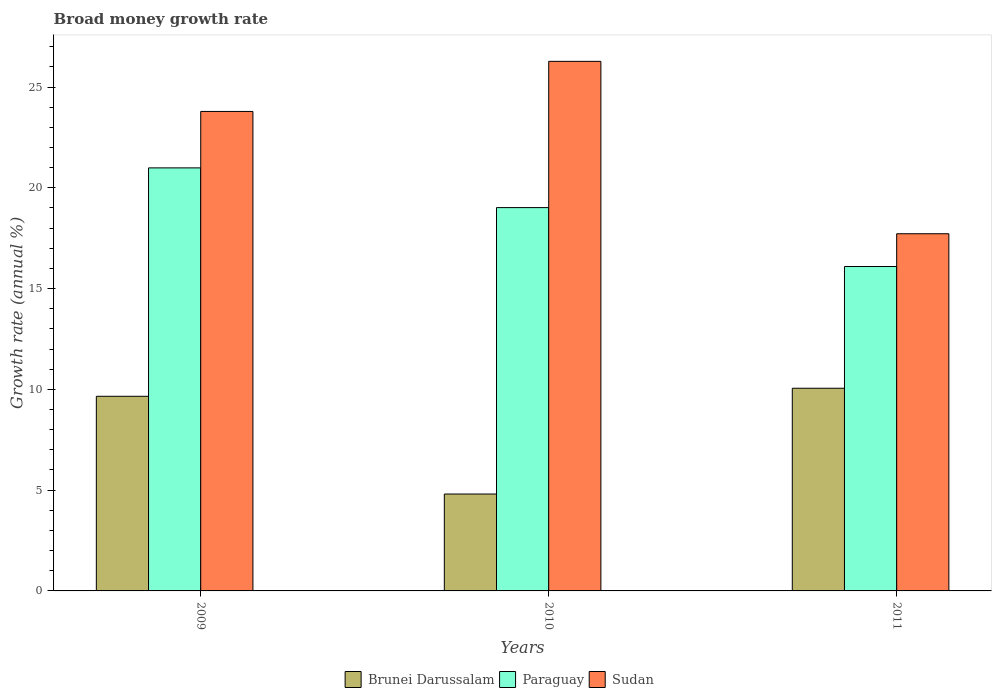How many different coloured bars are there?
Provide a succinct answer. 3. Are the number of bars on each tick of the X-axis equal?
Ensure brevity in your answer.  Yes. What is the label of the 2nd group of bars from the left?
Your answer should be very brief. 2010. What is the growth rate in Paraguay in 2009?
Offer a terse response. 20.99. Across all years, what is the maximum growth rate in Paraguay?
Offer a very short reply. 20.99. Across all years, what is the minimum growth rate in Brunei Darussalam?
Offer a terse response. 4.81. What is the total growth rate in Paraguay in the graph?
Keep it short and to the point. 56.1. What is the difference between the growth rate in Sudan in 2009 and that in 2010?
Your answer should be very brief. -2.49. What is the difference between the growth rate in Brunei Darussalam in 2011 and the growth rate in Sudan in 2009?
Keep it short and to the point. -13.73. What is the average growth rate in Sudan per year?
Your answer should be compact. 22.59. In the year 2011, what is the difference between the growth rate in Sudan and growth rate in Brunei Darussalam?
Offer a very short reply. 7.67. In how many years, is the growth rate in Paraguay greater than 25 %?
Your answer should be very brief. 0. What is the ratio of the growth rate in Brunei Darussalam in 2009 to that in 2010?
Offer a very short reply. 2.01. Is the growth rate in Paraguay in 2010 less than that in 2011?
Offer a very short reply. No. Is the difference between the growth rate in Sudan in 2009 and 2011 greater than the difference between the growth rate in Brunei Darussalam in 2009 and 2011?
Provide a short and direct response. Yes. What is the difference between the highest and the second highest growth rate in Sudan?
Give a very brief answer. 2.49. What is the difference between the highest and the lowest growth rate in Sudan?
Your answer should be compact. 8.55. In how many years, is the growth rate in Sudan greater than the average growth rate in Sudan taken over all years?
Offer a very short reply. 2. What does the 2nd bar from the left in 2010 represents?
Provide a short and direct response. Paraguay. What does the 1st bar from the right in 2009 represents?
Ensure brevity in your answer.  Sudan. Is it the case that in every year, the sum of the growth rate in Sudan and growth rate in Brunei Darussalam is greater than the growth rate in Paraguay?
Offer a very short reply. Yes. Are the values on the major ticks of Y-axis written in scientific E-notation?
Make the answer very short. No. Does the graph contain any zero values?
Your answer should be very brief. No. Does the graph contain grids?
Offer a very short reply. No. How are the legend labels stacked?
Offer a terse response. Horizontal. What is the title of the graph?
Make the answer very short. Broad money growth rate. Does "Guatemala" appear as one of the legend labels in the graph?
Offer a terse response. No. What is the label or title of the X-axis?
Provide a short and direct response. Years. What is the label or title of the Y-axis?
Offer a very short reply. Growth rate (annual %). What is the Growth rate (annual %) in Brunei Darussalam in 2009?
Keep it short and to the point. 9.66. What is the Growth rate (annual %) in Paraguay in 2009?
Offer a very short reply. 20.99. What is the Growth rate (annual %) of Sudan in 2009?
Keep it short and to the point. 23.79. What is the Growth rate (annual %) in Brunei Darussalam in 2010?
Your answer should be compact. 4.81. What is the Growth rate (annual %) of Paraguay in 2010?
Keep it short and to the point. 19.02. What is the Growth rate (annual %) in Sudan in 2010?
Your response must be concise. 26.27. What is the Growth rate (annual %) of Brunei Darussalam in 2011?
Keep it short and to the point. 10.05. What is the Growth rate (annual %) of Paraguay in 2011?
Ensure brevity in your answer.  16.09. What is the Growth rate (annual %) in Sudan in 2011?
Offer a terse response. 17.72. Across all years, what is the maximum Growth rate (annual %) of Brunei Darussalam?
Make the answer very short. 10.05. Across all years, what is the maximum Growth rate (annual %) of Paraguay?
Offer a terse response. 20.99. Across all years, what is the maximum Growth rate (annual %) in Sudan?
Give a very brief answer. 26.27. Across all years, what is the minimum Growth rate (annual %) of Brunei Darussalam?
Your answer should be compact. 4.81. Across all years, what is the minimum Growth rate (annual %) of Paraguay?
Give a very brief answer. 16.09. Across all years, what is the minimum Growth rate (annual %) of Sudan?
Ensure brevity in your answer.  17.72. What is the total Growth rate (annual %) in Brunei Darussalam in the graph?
Ensure brevity in your answer.  24.52. What is the total Growth rate (annual %) in Paraguay in the graph?
Give a very brief answer. 56.1. What is the total Growth rate (annual %) of Sudan in the graph?
Provide a short and direct response. 67.78. What is the difference between the Growth rate (annual %) of Brunei Darussalam in 2009 and that in 2010?
Your answer should be very brief. 4.85. What is the difference between the Growth rate (annual %) of Paraguay in 2009 and that in 2010?
Provide a short and direct response. 1.97. What is the difference between the Growth rate (annual %) of Sudan in 2009 and that in 2010?
Provide a short and direct response. -2.49. What is the difference between the Growth rate (annual %) of Brunei Darussalam in 2009 and that in 2011?
Ensure brevity in your answer.  -0.4. What is the difference between the Growth rate (annual %) of Paraguay in 2009 and that in 2011?
Ensure brevity in your answer.  4.89. What is the difference between the Growth rate (annual %) in Sudan in 2009 and that in 2011?
Keep it short and to the point. 6.07. What is the difference between the Growth rate (annual %) of Brunei Darussalam in 2010 and that in 2011?
Your answer should be very brief. -5.25. What is the difference between the Growth rate (annual %) in Paraguay in 2010 and that in 2011?
Offer a very short reply. 2.92. What is the difference between the Growth rate (annual %) of Sudan in 2010 and that in 2011?
Provide a short and direct response. 8.55. What is the difference between the Growth rate (annual %) of Brunei Darussalam in 2009 and the Growth rate (annual %) of Paraguay in 2010?
Provide a succinct answer. -9.36. What is the difference between the Growth rate (annual %) in Brunei Darussalam in 2009 and the Growth rate (annual %) in Sudan in 2010?
Your answer should be very brief. -16.62. What is the difference between the Growth rate (annual %) of Paraguay in 2009 and the Growth rate (annual %) of Sudan in 2010?
Offer a very short reply. -5.29. What is the difference between the Growth rate (annual %) in Brunei Darussalam in 2009 and the Growth rate (annual %) in Paraguay in 2011?
Provide a succinct answer. -6.44. What is the difference between the Growth rate (annual %) in Brunei Darussalam in 2009 and the Growth rate (annual %) in Sudan in 2011?
Offer a terse response. -8.06. What is the difference between the Growth rate (annual %) of Paraguay in 2009 and the Growth rate (annual %) of Sudan in 2011?
Provide a succinct answer. 3.27. What is the difference between the Growth rate (annual %) in Brunei Darussalam in 2010 and the Growth rate (annual %) in Paraguay in 2011?
Make the answer very short. -11.29. What is the difference between the Growth rate (annual %) in Brunei Darussalam in 2010 and the Growth rate (annual %) in Sudan in 2011?
Ensure brevity in your answer.  -12.91. What is the difference between the Growth rate (annual %) in Paraguay in 2010 and the Growth rate (annual %) in Sudan in 2011?
Make the answer very short. 1.3. What is the average Growth rate (annual %) of Brunei Darussalam per year?
Offer a very short reply. 8.17. What is the average Growth rate (annual %) in Paraguay per year?
Your response must be concise. 18.7. What is the average Growth rate (annual %) in Sudan per year?
Make the answer very short. 22.59. In the year 2009, what is the difference between the Growth rate (annual %) of Brunei Darussalam and Growth rate (annual %) of Paraguay?
Keep it short and to the point. -11.33. In the year 2009, what is the difference between the Growth rate (annual %) in Brunei Darussalam and Growth rate (annual %) in Sudan?
Provide a short and direct response. -14.13. In the year 2009, what is the difference between the Growth rate (annual %) in Paraguay and Growth rate (annual %) in Sudan?
Ensure brevity in your answer.  -2.8. In the year 2010, what is the difference between the Growth rate (annual %) of Brunei Darussalam and Growth rate (annual %) of Paraguay?
Offer a very short reply. -14.21. In the year 2010, what is the difference between the Growth rate (annual %) of Brunei Darussalam and Growth rate (annual %) of Sudan?
Provide a succinct answer. -21.47. In the year 2010, what is the difference between the Growth rate (annual %) of Paraguay and Growth rate (annual %) of Sudan?
Make the answer very short. -7.26. In the year 2011, what is the difference between the Growth rate (annual %) in Brunei Darussalam and Growth rate (annual %) in Paraguay?
Make the answer very short. -6.04. In the year 2011, what is the difference between the Growth rate (annual %) in Brunei Darussalam and Growth rate (annual %) in Sudan?
Your answer should be compact. -7.67. In the year 2011, what is the difference between the Growth rate (annual %) of Paraguay and Growth rate (annual %) of Sudan?
Offer a very short reply. -1.63. What is the ratio of the Growth rate (annual %) in Brunei Darussalam in 2009 to that in 2010?
Make the answer very short. 2.01. What is the ratio of the Growth rate (annual %) in Paraguay in 2009 to that in 2010?
Give a very brief answer. 1.1. What is the ratio of the Growth rate (annual %) in Sudan in 2009 to that in 2010?
Your answer should be compact. 0.91. What is the ratio of the Growth rate (annual %) in Brunei Darussalam in 2009 to that in 2011?
Ensure brevity in your answer.  0.96. What is the ratio of the Growth rate (annual %) in Paraguay in 2009 to that in 2011?
Offer a terse response. 1.3. What is the ratio of the Growth rate (annual %) of Sudan in 2009 to that in 2011?
Provide a succinct answer. 1.34. What is the ratio of the Growth rate (annual %) of Brunei Darussalam in 2010 to that in 2011?
Your answer should be compact. 0.48. What is the ratio of the Growth rate (annual %) of Paraguay in 2010 to that in 2011?
Your answer should be compact. 1.18. What is the ratio of the Growth rate (annual %) in Sudan in 2010 to that in 2011?
Give a very brief answer. 1.48. What is the difference between the highest and the second highest Growth rate (annual %) in Brunei Darussalam?
Your answer should be compact. 0.4. What is the difference between the highest and the second highest Growth rate (annual %) of Paraguay?
Offer a very short reply. 1.97. What is the difference between the highest and the second highest Growth rate (annual %) in Sudan?
Make the answer very short. 2.49. What is the difference between the highest and the lowest Growth rate (annual %) in Brunei Darussalam?
Offer a very short reply. 5.25. What is the difference between the highest and the lowest Growth rate (annual %) of Paraguay?
Give a very brief answer. 4.89. What is the difference between the highest and the lowest Growth rate (annual %) in Sudan?
Ensure brevity in your answer.  8.55. 